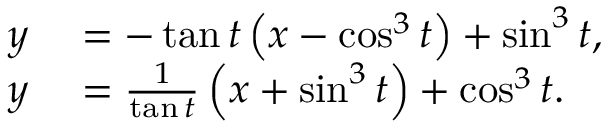Convert formula to latex. <formula><loc_0><loc_0><loc_500><loc_500>\begin{array} { r l } { y } & = - \tan t \left ( x - \cos ^ { 3 } t \right ) + \sin ^ { 3 } t , } \\ { y } & = { \frac { 1 } { \tan t } } \left ( x + \sin ^ { 3 } t \right ) + \cos ^ { 3 } t . } \end{array}</formula> 